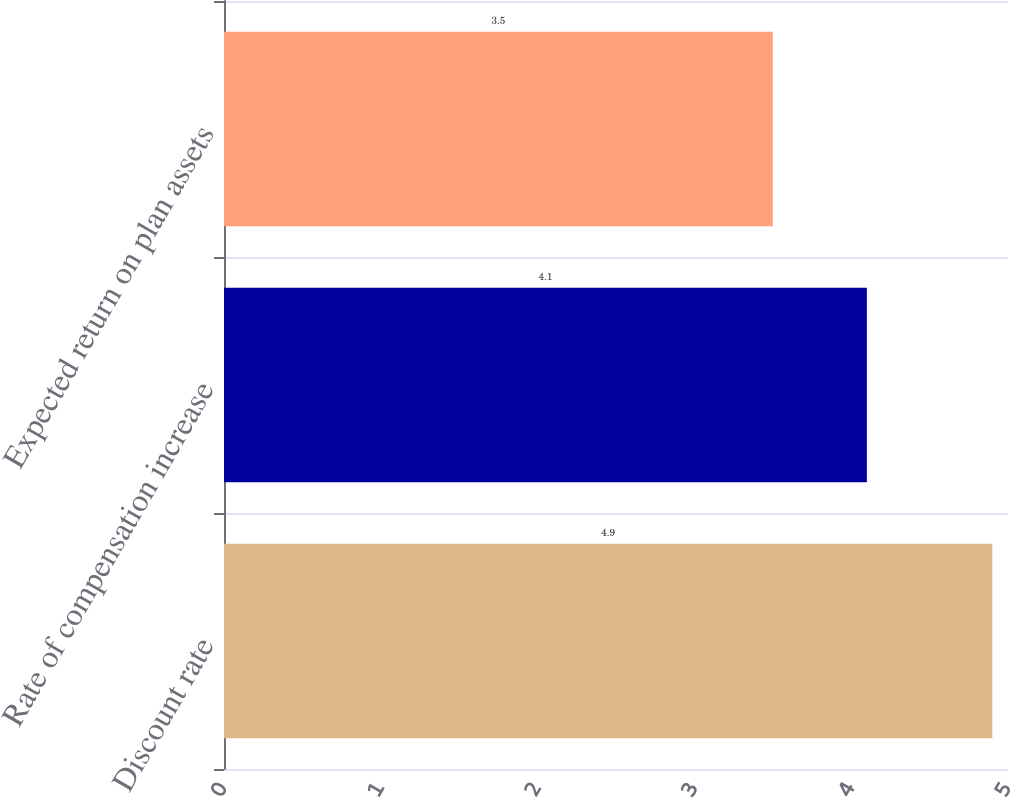Convert chart. <chart><loc_0><loc_0><loc_500><loc_500><bar_chart><fcel>Discount rate<fcel>Rate of compensation increase<fcel>Expected return on plan assets<nl><fcel>4.9<fcel>4.1<fcel>3.5<nl></chart> 